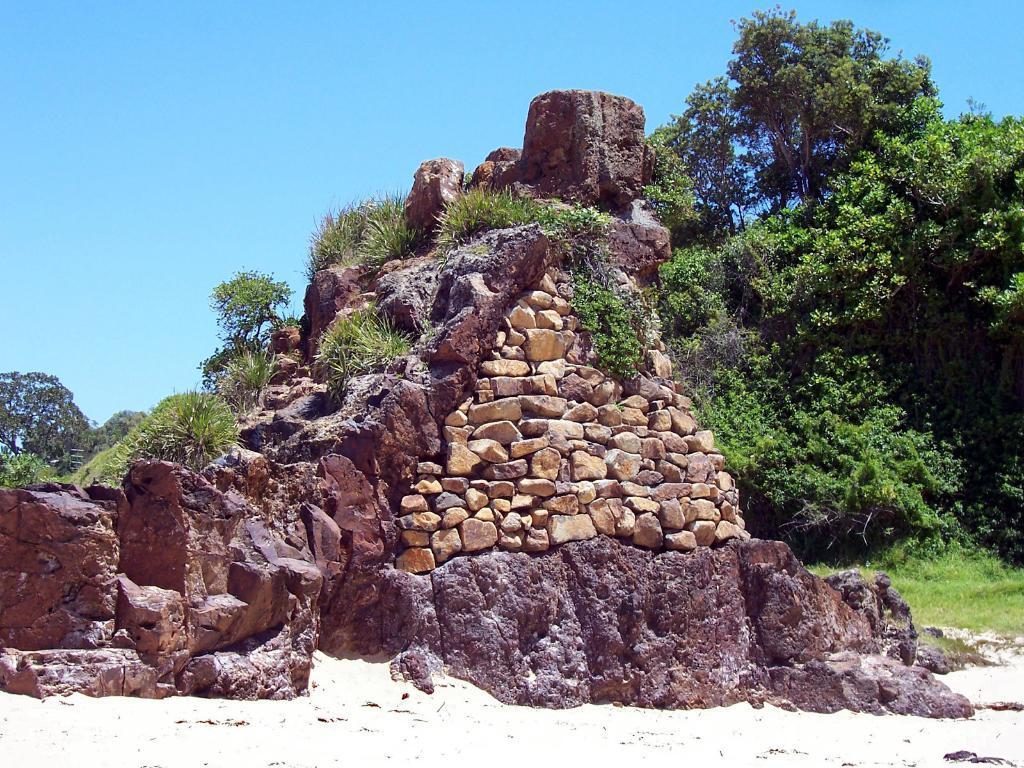Please provide a concise description of this image. In this image we can see stones, rocks, plants and trees on the ground and we can see the sky. 